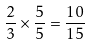Convert formula to latex. <formula><loc_0><loc_0><loc_500><loc_500>\frac { 2 } { 3 } \times \frac { 5 } { 5 } = \frac { 1 0 } { 1 5 }</formula> 